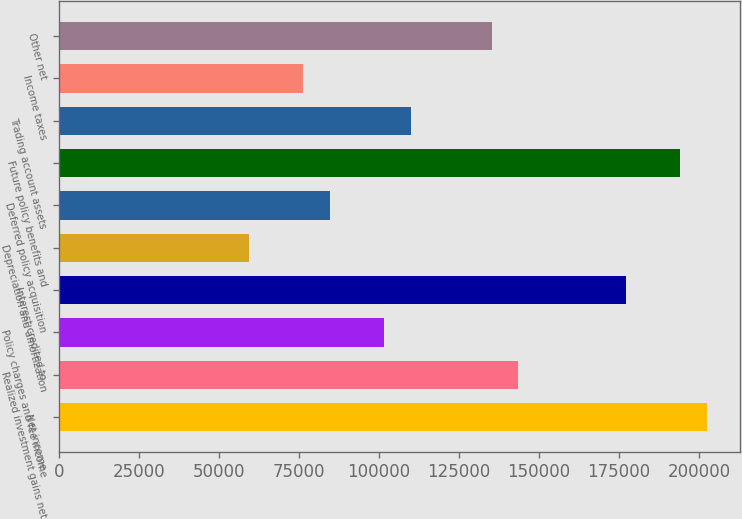Convert chart. <chart><loc_0><loc_0><loc_500><loc_500><bar_chart><fcel>Net income<fcel>Realized investment gains net<fcel>Policy charges and fee income<fcel>Interest credited to<fcel>Depreciation and amortization<fcel>Deferred policy acquisition<fcel>Future policy benefits and<fcel>Trading account assets<fcel>Income taxes<fcel>Other net<nl><fcel>202703<fcel>143584<fcel>101356<fcel>177367<fcel>59128.2<fcel>84465<fcel>194258<fcel>109802<fcel>76019.4<fcel>135139<nl></chart> 